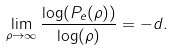<formula> <loc_0><loc_0><loc_500><loc_500>\lim _ { \rho \rightarrow \infty } \frac { \log ( P _ { e } ( \rho ) ) } { \log ( \rho ) } = - d .</formula> 